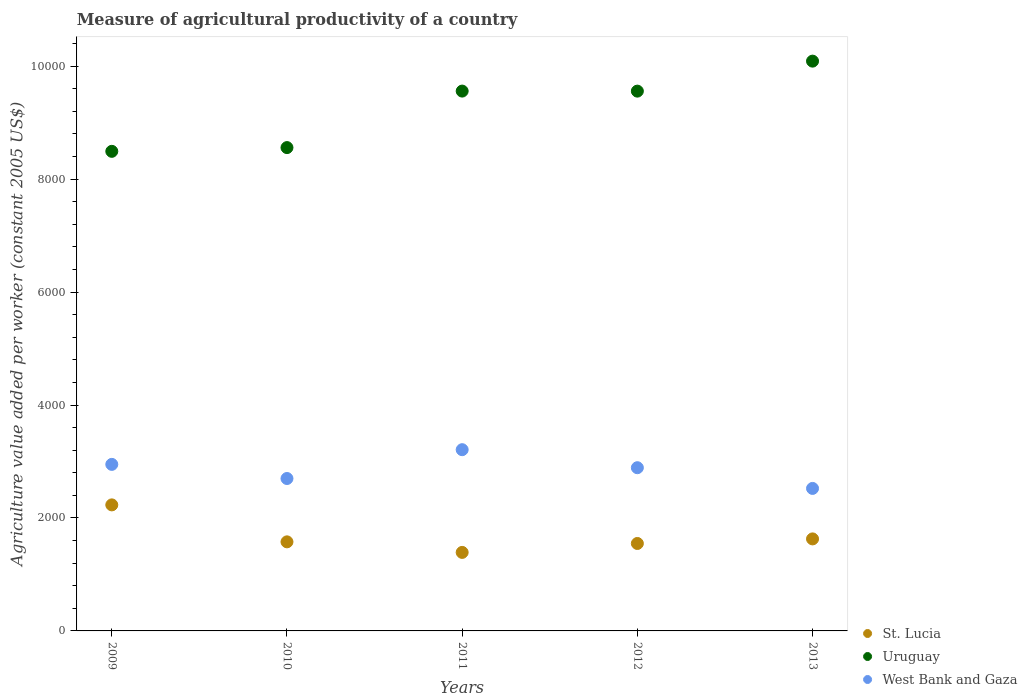What is the measure of agricultural productivity in St. Lucia in 2013?
Ensure brevity in your answer.  1629.35. Across all years, what is the maximum measure of agricultural productivity in St. Lucia?
Offer a terse response. 2231.67. Across all years, what is the minimum measure of agricultural productivity in West Bank and Gaza?
Your response must be concise. 2523.12. In which year was the measure of agricultural productivity in Uruguay maximum?
Ensure brevity in your answer.  2013. In which year was the measure of agricultural productivity in St. Lucia minimum?
Offer a very short reply. 2011. What is the total measure of agricultural productivity in Uruguay in the graph?
Your answer should be compact. 4.63e+04. What is the difference between the measure of agricultural productivity in West Bank and Gaza in 2010 and that in 2011?
Keep it short and to the point. -510.41. What is the difference between the measure of agricultural productivity in Uruguay in 2010 and the measure of agricultural productivity in West Bank and Gaza in 2012?
Your response must be concise. 5668.18. What is the average measure of agricultural productivity in Uruguay per year?
Your answer should be compact. 9251. In the year 2009, what is the difference between the measure of agricultural productivity in Uruguay and measure of agricultural productivity in West Bank and Gaza?
Ensure brevity in your answer.  5542.98. In how many years, is the measure of agricultural productivity in Uruguay greater than 1600 US$?
Make the answer very short. 5. What is the ratio of the measure of agricultural productivity in West Bank and Gaza in 2009 to that in 2010?
Provide a short and direct response. 1.09. What is the difference between the highest and the second highest measure of agricultural productivity in West Bank and Gaza?
Your answer should be very brief. 260.26. What is the difference between the highest and the lowest measure of agricultural productivity in West Bank and Gaza?
Offer a terse response. 685.93. Is the measure of agricultural productivity in St. Lucia strictly greater than the measure of agricultural productivity in Uruguay over the years?
Offer a very short reply. No. How many dotlines are there?
Your answer should be compact. 3. What is the difference between two consecutive major ticks on the Y-axis?
Offer a very short reply. 2000. Are the values on the major ticks of Y-axis written in scientific E-notation?
Your answer should be compact. No. Where does the legend appear in the graph?
Give a very brief answer. Bottom right. How many legend labels are there?
Offer a very short reply. 3. What is the title of the graph?
Make the answer very short. Measure of agricultural productivity of a country. Does "Algeria" appear as one of the legend labels in the graph?
Your response must be concise. No. What is the label or title of the Y-axis?
Make the answer very short. Agriculture value added per worker (constant 2005 US$). What is the Agriculture value added per worker (constant 2005 US$) of St. Lucia in 2009?
Your answer should be very brief. 2231.67. What is the Agriculture value added per worker (constant 2005 US$) in Uruguay in 2009?
Provide a succinct answer. 8491.77. What is the Agriculture value added per worker (constant 2005 US$) in West Bank and Gaza in 2009?
Make the answer very short. 2948.79. What is the Agriculture value added per worker (constant 2005 US$) of St. Lucia in 2010?
Keep it short and to the point. 1577.21. What is the Agriculture value added per worker (constant 2005 US$) of Uruguay in 2010?
Ensure brevity in your answer.  8558.06. What is the Agriculture value added per worker (constant 2005 US$) in West Bank and Gaza in 2010?
Offer a very short reply. 2698.64. What is the Agriculture value added per worker (constant 2005 US$) of St. Lucia in 2011?
Your answer should be very brief. 1390.22. What is the Agriculture value added per worker (constant 2005 US$) of Uruguay in 2011?
Your response must be concise. 9558.51. What is the Agriculture value added per worker (constant 2005 US$) of West Bank and Gaza in 2011?
Offer a very short reply. 3209.05. What is the Agriculture value added per worker (constant 2005 US$) in St. Lucia in 2012?
Ensure brevity in your answer.  1548.38. What is the Agriculture value added per worker (constant 2005 US$) of Uruguay in 2012?
Your answer should be compact. 9557.83. What is the Agriculture value added per worker (constant 2005 US$) of West Bank and Gaza in 2012?
Your response must be concise. 2889.88. What is the Agriculture value added per worker (constant 2005 US$) of St. Lucia in 2013?
Offer a very short reply. 1629.35. What is the Agriculture value added per worker (constant 2005 US$) in Uruguay in 2013?
Provide a short and direct response. 1.01e+04. What is the Agriculture value added per worker (constant 2005 US$) of West Bank and Gaza in 2013?
Make the answer very short. 2523.12. Across all years, what is the maximum Agriculture value added per worker (constant 2005 US$) of St. Lucia?
Your response must be concise. 2231.67. Across all years, what is the maximum Agriculture value added per worker (constant 2005 US$) in Uruguay?
Offer a terse response. 1.01e+04. Across all years, what is the maximum Agriculture value added per worker (constant 2005 US$) in West Bank and Gaza?
Give a very brief answer. 3209.05. Across all years, what is the minimum Agriculture value added per worker (constant 2005 US$) in St. Lucia?
Offer a very short reply. 1390.22. Across all years, what is the minimum Agriculture value added per worker (constant 2005 US$) in Uruguay?
Your response must be concise. 8491.77. Across all years, what is the minimum Agriculture value added per worker (constant 2005 US$) of West Bank and Gaza?
Your answer should be very brief. 2523.12. What is the total Agriculture value added per worker (constant 2005 US$) in St. Lucia in the graph?
Keep it short and to the point. 8376.84. What is the total Agriculture value added per worker (constant 2005 US$) of Uruguay in the graph?
Give a very brief answer. 4.63e+04. What is the total Agriculture value added per worker (constant 2005 US$) in West Bank and Gaza in the graph?
Ensure brevity in your answer.  1.43e+04. What is the difference between the Agriculture value added per worker (constant 2005 US$) of St. Lucia in 2009 and that in 2010?
Keep it short and to the point. 654.47. What is the difference between the Agriculture value added per worker (constant 2005 US$) of Uruguay in 2009 and that in 2010?
Provide a short and direct response. -66.29. What is the difference between the Agriculture value added per worker (constant 2005 US$) of West Bank and Gaza in 2009 and that in 2010?
Provide a succinct answer. 250.14. What is the difference between the Agriculture value added per worker (constant 2005 US$) in St. Lucia in 2009 and that in 2011?
Offer a very short reply. 841.45. What is the difference between the Agriculture value added per worker (constant 2005 US$) in Uruguay in 2009 and that in 2011?
Give a very brief answer. -1066.73. What is the difference between the Agriculture value added per worker (constant 2005 US$) in West Bank and Gaza in 2009 and that in 2011?
Keep it short and to the point. -260.26. What is the difference between the Agriculture value added per worker (constant 2005 US$) of St. Lucia in 2009 and that in 2012?
Offer a very short reply. 683.29. What is the difference between the Agriculture value added per worker (constant 2005 US$) in Uruguay in 2009 and that in 2012?
Your answer should be compact. -1066.06. What is the difference between the Agriculture value added per worker (constant 2005 US$) in West Bank and Gaza in 2009 and that in 2012?
Offer a very short reply. 58.91. What is the difference between the Agriculture value added per worker (constant 2005 US$) of St. Lucia in 2009 and that in 2013?
Give a very brief answer. 602.32. What is the difference between the Agriculture value added per worker (constant 2005 US$) in Uruguay in 2009 and that in 2013?
Provide a succinct answer. -1597.08. What is the difference between the Agriculture value added per worker (constant 2005 US$) in West Bank and Gaza in 2009 and that in 2013?
Give a very brief answer. 425.67. What is the difference between the Agriculture value added per worker (constant 2005 US$) of St. Lucia in 2010 and that in 2011?
Your answer should be compact. 186.98. What is the difference between the Agriculture value added per worker (constant 2005 US$) of Uruguay in 2010 and that in 2011?
Give a very brief answer. -1000.45. What is the difference between the Agriculture value added per worker (constant 2005 US$) in West Bank and Gaza in 2010 and that in 2011?
Your answer should be very brief. -510.41. What is the difference between the Agriculture value added per worker (constant 2005 US$) in St. Lucia in 2010 and that in 2012?
Your response must be concise. 28.82. What is the difference between the Agriculture value added per worker (constant 2005 US$) of Uruguay in 2010 and that in 2012?
Offer a very short reply. -999.77. What is the difference between the Agriculture value added per worker (constant 2005 US$) in West Bank and Gaza in 2010 and that in 2012?
Give a very brief answer. -191.24. What is the difference between the Agriculture value added per worker (constant 2005 US$) of St. Lucia in 2010 and that in 2013?
Your response must be concise. -52.15. What is the difference between the Agriculture value added per worker (constant 2005 US$) of Uruguay in 2010 and that in 2013?
Your answer should be compact. -1530.79. What is the difference between the Agriculture value added per worker (constant 2005 US$) of West Bank and Gaza in 2010 and that in 2013?
Ensure brevity in your answer.  175.52. What is the difference between the Agriculture value added per worker (constant 2005 US$) of St. Lucia in 2011 and that in 2012?
Give a very brief answer. -158.16. What is the difference between the Agriculture value added per worker (constant 2005 US$) of Uruguay in 2011 and that in 2012?
Give a very brief answer. 0.68. What is the difference between the Agriculture value added per worker (constant 2005 US$) of West Bank and Gaza in 2011 and that in 2012?
Provide a succinct answer. 319.17. What is the difference between the Agriculture value added per worker (constant 2005 US$) in St. Lucia in 2011 and that in 2013?
Keep it short and to the point. -239.13. What is the difference between the Agriculture value added per worker (constant 2005 US$) of Uruguay in 2011 and that in 2013?
Keep it short and to the point. -530.35. What is the difference between the Agriculture value added per worker (constant 2005 US$) of West Bank and Gaza in 2011 and that in 2013?
Keep it short and to the point. 685.93. What is the difference between the Agriculture value added per worker (constant 2005 US$) in St. Lucia in 2012 and that in 2013?
Your response must be concise. -80.97. What is the difference between the Agriculture value added per worker (constant 2005 US$) in Uruguay in 2012 and that in 2013?
Provide a succinct answer. -531.02. What is the difference between the Agriculture value added per worker (constant 2005 US$) of West Bank and Gaza in 2012 and that in 2013?
Give a very brief answer. 366.76. What is the difference between the Agriculture value added per worker (constant 2005 US$) of St. Lucia in 2009 and the Agriculture value added per worker (constant 2005 US$) of Uruguay in 2010?
Give a very brief answer. -6326.39. What is the difference between the Agriculture value added per worker (constant 2005 US$) of St. Lucia in 2009 and the Agriculture value added per worker (constant 2005 US$) of West Bank and Gaza in 2010?
Offer a terse response. -466.97. What is the difference between the Agriculture value added per worker (constant 2005 US$) of Uruguay in 2009 and the Agriculture value added per worker (constant 2005 US$) of West Bank and Gaza in 2010?
Your response must be concise. 5793.13. What is the difference between the Agriculture value added per worker (constant 2005 US$) in St. Lucia in 2009 and the Agriculture value added per worker (constant 2005 US$) in Uruguay in 2011?
Your answer should be very brief. -7326.83. What is the difference between the Agriculture value added per worker (constant 2005 US$) of St. Lucia in 2009 and the Agriculture value added per worker (constant 2005 US$) of West Bank and Gaza in 2011?
Your response must be concise. -977.38. What is the difference between the Agriculture value added per worker (constant 2005 US$) in Uruguay in 2009 and the Agriculture value added per worker (constant 2005 US$) in West Bank and Gaza in 2011?
Give a very brief answer. 5282.72. What is the difference between the Agriculture value added per worker (constant 2005 US$) in St. Lucia in 2009 and the Agriculture value added per worker (constant 2005 US$) in Uruguay in 2012?
Offer a terse response. -7326.16. What is the difference between the Agriculture value added per worker (constant 2005 US$) in St. Lucia in 2009 and the Agriculture value added per worker (constant 2005 US$) in West Bank and Gaza in 2012?
Keep it short and to the point. -658.21. What is the difference between the Agriculture value added per worker (constant 2005 US$) of Uruguay in 2009 and the Agriculture value added per worker (constant 2005 US$) of West Bank and Gaza in 2012?
Make the answer very short. 5601.89. What is the difference between the Agriculture value added per worker (constant 2005 US$) in St. Lucia in 2009 and the Agriculture value added per worker (constant 2005 US$) in Uruguay in 2013?
Provide a succinct answer. -7857.18. What is the difference between the Agriculture value added per worker (constant 2005 US$) of St. Lucia in 2009 and the Agriculture value added per worker (constant 2005 US$) of West Bank and Gaza in 2013?
Offer a terse response. -291.45. What is the difference between the Agriculture value added per worker (constant 2005 US$) of Uruguay in 2009 and the Agriculture value added per worker (constant 2005 US$) of West Bank and Gaza in 2013?
Your answer should be compact. 5968.65. What is the difference between the Agriculture value added per worker (constant 2005 US$) of St. Lucia in 2010 and the Agriculture value added per worker (constant 2005 US$) of Uruguay in 2011?
Offer a very short reply. -7981.3. What is the difference between the Agriculture value added per worker (constant 2005 US$) of St. Lucia in 2010 and the Agriculture value added per worker (constant 2005 US$) of West Bank and Gaza in 2011?
Your response must be concise. -1631.85. What is the difference between the Agriculture value added per worker (constant 2005 US$) in Uruguay in 2010 and the Agriculture value added per worker (constant 2005 US$) in West Bank and Gaza in 2011?
Keep it short and to the point. 5349.01. What is the difference between the Agriculture value added per worker (constant 2005 US$) of St. Lucia in 2010 and the Agriculture value added per worker (constant 2005 US$) of Uruguay in 2012?
Offer a terse response. -7980.62. What is the difference between the Agriculture value added per worker (constant 2005 US$) in St. Lucia in 2010 and the Agriculture value added per worker (constant 2005 US$) in West Bank and Gaza in 2012?
Your answer should be very brief. -1312.68. What is the difference between the Agriculture value added per worker (constant 2005 US$) of Uruguay in 2010 and the Agriculture value added per worker (constant 2005 US$) of West Bank and Gaza in 2012?
Your answer should be very brief. 5668.18. What is the difference between the Agriculture value added per worker (constant 2005 US$) in St. Lucia in 2010 and the Agriculture value added per worker (constant 2005 US$) in Uruguay in 2013?
Provide a succinct answer. -8511.65. What is the difference between the Agriculture value added per worker (constant 2005 US$) of St. Lucia in 2010 and the Agriculture value added per worker (constant 2005 US$) of West Bank and Gaza in 2013?
Your answer should be compact. -945.92. What is the difference between the Agriculture value added per worker (constant 2005 US$) of Uruguay in 2010 and the Agriculture value added per worker (constant 2005 US$) of West Bank and Gaza in 2013?
Offer a very short reply. 6034.94. What is the difference between the Agriculture value added per worker (constant 2005 US$) of St. Lucia in 2011 and the Agriculture value added per worker (constant 2005 US$) of Uruguay in 2012?
Give a very brief answer. -8167.61. What is the difference between the Agriculture value added per worker (constant 2005 US$) of St. Lucia in 2011 and the Agriculture value added per worker (constant 2005 US$) of West Bank and Gaza in 2012?
Provide a short and direct response. -1499.66. What is the difference between the Agriculture value added per worker (constant 2005 US$) in Uruguay in 2011 and the Agriculture value added per worker (constant 2005 US$) in West Bank and Gaza in 2012?
Offer a very short reply. 6668.62. What is the difference between the Agriculture value added per worker (constant 2005 US$) of St. Lucia in 2011 and the Agriculture value added per worker (constant 2005 US$) of Uruguay in 2013?
Ensure brevity in your answer.  -8698.63. What is the difference between the Agriculture value added per worker (constant 2005 US$) of St. Lucia in 2011 and the Agriculture value added per worker (constant 2005 US$) of West Bank and Gaza in 2013?
Offer a very short reply. -1132.9. What is the difference between the Agriculture value added per worker (constant 2005 US$) of Uruguay in 2011 and the Agriculture value added per worker (constant 2005 US$) of West Bank and Gaza in 2013?
Provide a short and direct response. 7035.38. What is the difference between the Agriculture value added per worker (constant 2005 US$) of St. Lucia in 2012 and the Agriculture value added per worker (constant 2005 US$) of Uruguay in 2013?
Provide a succinct answer. -8540.47. What is the difference between the Agriculture value added per worker (constant 2005 US$) of St. Lucia in 2012 and the Agriculture value added per worker (constant 2005 US$) of West Bank and Gaza in 2013?
Ensure brevity in your answer.  -974.74. What is the difference between the Agriculture value added per worker (constant 2005 US$) of Uruguay in 2012 and the Agriculture value added per worker (constant 2005 US$) of West Bank and Gaza in 2013?
Offer a very short reply. 7034.71. What is the average Agriculture value added per worker (constant 2005 US$) of St. Lucia per year?
Give a very brief answer. 1675.37. What is the average Agriculture value added per worker (constant 2005 US$) in Uruguay per year?
Offer a very short reply. 9251. What is the average Agriculture value added per worker (constant 2005 US$) in West Bank and Gaza per year?
Provide a succinct answer. 2853.9. In the year 2009, what is the difference between the Agriculture value added per worker (constant 2005 US$) of St. Lucia and Agriculture value added per worker (constant 2005 US$) of Uruguay?
Your answer should be compact. -6260.1. In the year 2009, what is the difference between the Agriculture value added per worker (constant 2005 US$) of St. Lucia and Agriculture value added per worker (constant 2005 US$) of West Bank and Gaza?
Your answer should be compact. -717.11. In the year 2009, what is the difference between the Agriculture value added per worker (constant 2005 US$) of Uruguay and Agriculture value added per worker (constant 2005 US$) of West Bank and Gaza?
Ensure brevity in your answer.  5542.98. In the year 2010, what is the difference between the Agriculture value added per worker (constant 2005 US$) in St. Lucia and Agriculture value added per worker (constant 2005 US$) in Uruguay?
Make the answer very short. -6980.85. In the year 2010, what is the difference between the Agriculture value added per worker (constant 2005 US$) in St. Lucia and Agriculture value added per worker (constant 2005 US$) in West Bank and Gaza?
Make the answer very short. -1121.44. In the year 2010, what is the difference between the Agriculture value added per worker (constant 2005 US$) in Uruguay and Agriculture value added per worker (constant 2005 US$) in West Bank and Gaza?
Give a very brief answer. 5859.42. In the year 2011, what is the difference between the Agriculture value added per worker (constant 2005 US$) of St. Lucia and Agriculture value added per worker (constant 2005 US$) of Uruguay?
Offer a very short reply. -8168.28. In the year 2011, what is the difference between the Agriculture value added per worker (constant 2005 US$) of St. Lucia and Agriculture value added per worker (constant 2005 US$) of West Bank and Gaza?
Your answer should be compact. -1818.83. In the year 2011, what is the difference between the Agriculture value added per worker (constant 2005 US$) in Uruguay and Agriculture value added per worker (constant 2005 US$) in West Bank and Gaza?
Your answer should be compact. 6349.45. In the year 2012, what is the difference between the Agriculture value added per worker (constant 2005 US$) in St. Lucia and Agriculture value added per worker (constant 2005 US$) in Uruguay?
Your response must be concise. -8009.45. In the year 2012, what is the difference between the Agriculture value added per worker (constant 2005 US$) in St. Lucia and Agriculture value added per worker (constant 2005 US$) in West Bank and Gaza?
Give a very brief answer. -1341.5. In the year 2012, what is the difference between the Agriculture value added per worker (constant 2005 US$) in Uruguay and Agriculture value added per worker (constant 2005 US$) in West Bank and Gaza?
Offer a very short reply. 6667.95. In the year 2013, what is the difference between the Agriculture value added per worker (constant 2005 US$) of St. Lucia and Agriculture value added per worker (constant 2005 US$) of Uruguay?
Your response must be concise. -8459.5. In the year 2013, what is the difference between the Agriculture value added per worker (constant 2005 US$) of St. Lucia and Agriculture value added per worker (constant 2005 US$) of West Bank and Gaza?
Offer a very short reply. -893.77. In the year 2013, what is the difference between the Agriculture value added per worker (constant 2005 US$) in Uruguay and Agriculture value added per worker (constant 2005 US$) in West Bank and Gaza?
Make the answer very short. 7565.73. What is the ratio of the Agriculture value added per worker (constant 2005 US$) in St. Lucia in 2009 to that in 2010?
Give a very brief answer. 1.42. What is the ratio of the Agriculture value added per worker (constant 2005 US$) in West Bank and Gaza in 2009 to that in 2010?
Provide a succinct answer. 1.09. What is the ratio of the Agriculture value added per worker (constant 2005 US$) of St. Lucia in 2009 to that in 2011?
Your answer should be very brief. 1.61. What is the ratio of the Agriculture value added per worker (constant 2005 US$) in Uruguay in 2009 to that in 2011?
Ensure brevity in your answer.  0.89. What is the ratio of the Agriculture value added per worker (constant 2005 US$) in West Bank and Gaza in 2009 to that in 2011?
Offer a very short reply. 0.92. What is the ratio of the Agriculture value added per worker (constant 2005 US$) in St. Lucia in 2009 to that in 2012?
Your response must be concise. 1.44. What is the ratio of the Agriculture value added per worker (constant 2005 US$) in Uruguay in 2009 to that in 2012?
Provide a succinct answer. 0.89. What is the ratio of the Agriculture value added per worker (constant 2005 US$) of West Bank and Gaza in 2009 to that in 2012?
Your answer should be compact. 1.02. What is the ratio of the Agriculture value added per worker (constant 2005 US$) of St. Lucia in 2009 to that in 2013?
Provide a short and direct response. 1.37. What is the ratio of the Agriculture value added per worker (constant 2005 US$) of Uruguay in 2009 to that in 2013?
Provide a short and direct response. 0.84. What is the ratio of the Agriculture value added per worker (constant 2005 US$) in West Bank and Gaza in 2009 to that in 2013?
Offer a terse response. 1.17. What is the ratio of the Agriculture value added per worker (constant 2005 US$) in St. Lucia in 2010 to that in 2011?
Give a very brief answer. 1.13. What is the ratio of the Agriculture value added per worker (constant 2005 US$) of Uruguay in 2010 to that in 2011?
Your response must be concise. 0.9. What is the ratio of the Agriculture value added per worker (constant 2005 US$) of West Bank and Gaza in 2010 to that in 2011?
Provide a succinct answer. 0.84. What is the ratio of the Agriculture value added per worker (constant 2005 US$) in St. Lucia in 2010 to that in 2012?
Offer a very short reply. 1.02. What is the ratio of the Agriculture value added per worker (constant 2005 US$) of Uruguay in 2010 to that in 2012?
Provide a short and direct response. 0.9. What is the ratio of the Agriculture value added per worker (constant 2005 US$) of West Bank and Gaza in 2010 to that in 2012?
Your response must be concise. 0.93. What is the ratio of the Agriculture value added per worker (constant 2005 US$) in Uruguay in 2010 to that in 2013?
Your answer should be very brief. 0.85. What is the ratio of the Agriculture value added per worker (constant 2005 US$) in West Bank and Gaza in 2010 to that in 2013?
Your answer should be compact. 1.07. What is the ratio of the Agriculture value added per worker (constant 2005 US$) of St. Lucia in 2011 to that in 2012?
Offer a very short reply. 0.9. What is the ratio of the Agriculture value added per worker (constant 2005 US$) in West Bank and Gaza in 2011 to that in 2012?
Your answer should be very brief. 1.11. What is the ratio of the Agriculture value added per worker (constant 2005 US$) in St. Lucia in 2011 to that in 2013?
Your response must be concise. 0.85. What is the ratio of the Agriculture value added per worker (constant 2005 US$) in West Bank and Gaza in 2011 to that in 2013?
Offer a very short reply. 1.27. What is the ratio of the Agriculture value added per worker (constant 2005 US$) in St. Lucia in 2012 to that in 2013?
Give a very brief answer. 0.95. What is the ratio of the Agriculture value added per worker (constant 2005 US$) of West Bank and Gaza in 2012 to that in 2013?
Make the answer very short. 1.15. What is the difference between the highest and the second highest Agriculture value added per worker (constant 2005 US$) of St. Lucia?
Offer a very short reply. 602.32. What is the difference between the highest and the second highest Agriculture value added per worker (constant 2005 US$) of Uruguay?
Your response must be concise. 530.35. What is the difference between the highest and the second highest Agriculture value added per worker (constant 2005 US$) of West Bank and Gaza?
Provide a succinct answer. 260.26. What is the difference between the highest and the lowest Agriculture value added per worker (constant 2005 US$) of St. Lucia?
Ensure brevity in your answer.  841.45. What is the difference between the highest and the lowest Agriculture value added per worker (constant 2005 US$) in Uruguay?
Provide a short and direct response. 1597.08. What is the difference between the highest and the lowest Agriculture value added per worker (constant 2005 US$) in West Bank and Gaza?
Your answer should be compact. 685.93. 